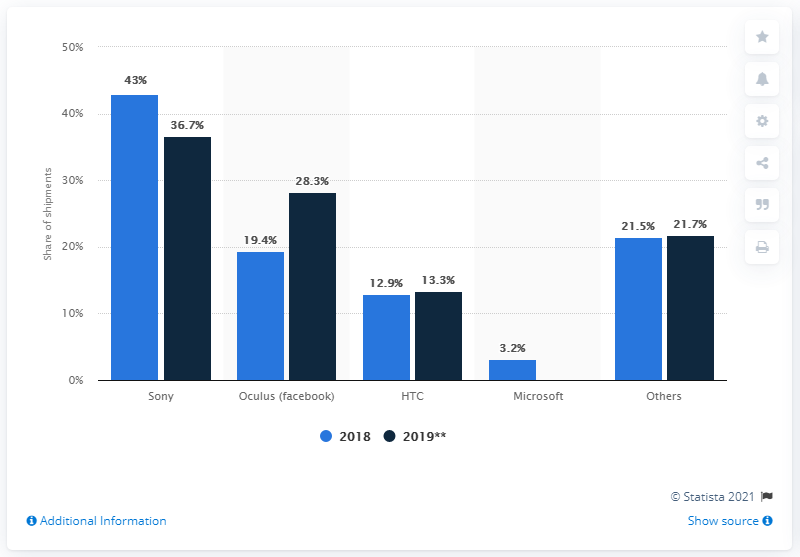Identify some key points in this picture. Sony is expected to account for approximately 36.7% of VR device shipments in 2019. 